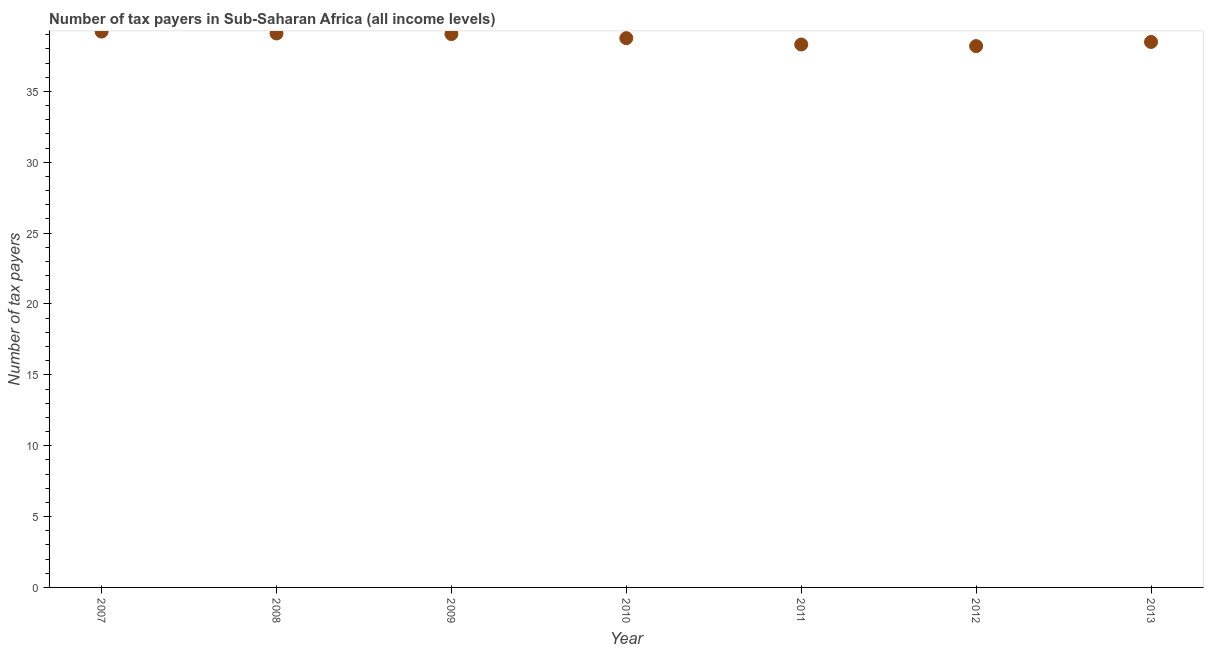What is the number of tax payers in 2011?
Provide a succinct answer. 38.31. Across all years, what is the maximum number of tax payers?
Your answer should be compact. 39.22. Across all years, what is the minimum number of tax payers?
Your answer should be compact. 38.2. In which year was the number of tax payers maximum?
Keep it short and to the point. 2007. What is the sum of the number of tax payers?
Make the answer very short. 271.11. What is the difference between the number of tax payers in 2009 and 2011?
Provide a short and direct response. 0.73. What is the average number of tax payers per year?
Make the answer very short. 38.73. What is the median number of tax payers?
Your answer should be compact. 38.76. Do a majority of the years between 2009 and 2008 (inclusive) have number of tax payers greater than 10 ?
Offer a terse response. No. What is the ratio of the number of tax payers in 2007 to that in 2010?
Ensure brevity in your answer.  1.01. Is the number of tax payers in 2009 less than that in 2010?
Make the answer very short. No. Is the difference between the number of tax payers in 2007 and 2009 greater than the difference between any two years?
Your response must be concise. No. What is the difference between the highest and the second highest number of tax payers?
Give a very brief answer. 0.13. Is the sum of the number of tax payers in 2007 and 2013 greater than the maximum number of tax payers across all years?
Your answer should be very brief. Yes. What is the difference between the highest and the lowest number of tax payers?
Your answer should be compact. 1.03. Does the number of tax payers monotonically increase over the years?
Provide a short and direct response. No. How many dotlines are there?
Ensure brevity in your answer.  1. How many years are there in the graph?
Your response must be concise. 7. What is the difference between two consecutive major ticks on the Y-axis?
Provide a short and direct response. 5. Does the graph contain any zero values?
Your answer should be compact. No. Does the graph contain grids?
Your answer should be compact. No. What is the title of the graph?
Ensure brevity in your answer.  Number of tax payers in Sub-Saharan Africa (all income levels). What is the label or title of the X-axis?
Make the answer very short. Year. What is the label or title of the Y-axis?
Provide a succinct answer. Number of tax payers. What is the Number of tax payers in 2007?
Your answer should be compact. 39.22. What is the Number of tax payers in 2008?
Make the answer very short. 39.09. What is the Number of tax payers in 2009?
Offer a terse response. 39.04. What is the Number of tax payers in 2010?
Ensure brevity in your answer.  38.76. What is the Number of tax payers in 2011?
Ensure brevity in your answer.  38.31. What is the Number of tax payers in 2012?
Keep it short and to the point. 38.2. What is the Number of tax payers in 2013?
Provide a short and direct response. 38.49. What is the difference between the Number of tax payers in 2007 and 2008?
Provide a short and direct response. 0.13. What is the difference between the Number of tax payers in 2007 and 2009?
Provide a succinct answer. 0.18. What is the difference between the Number of tax payers in 2007 and 2010?
Offer a terse response. 0.47. What is the difference between the Number of tax payers in 2007 and 2011?
Your response must be concise. 0.91. What is the difference between the Number of tax payers in 2007 and 2012?
Ensure brevity in your answer.  1.03. What is the difference between the Number of tax payers in 2007 and 2013?
Provide a succinct answer. 0.73. What is the difference between the Number of tax payers in 2008 and 2009?
Provide a short and direct response. 0.04. What is the difference between the Number of tax payers in 2008 and 2010?
Offer a very short reply. 0.33. What is the difference between the Number of tax payers in 2008 and 2011?
Keep it short and to the point. 0.78. What is the difference between the Number of tax payers in 2008 and 2012?
Your answer should be compact. 0.89. What is the difference between the Number of tax payers in 2008 and 2013?
Give a very brief answer. 0.6. What is the difference between the Number of tax payers in 2009 and 2010?
Your answer should be very brief. 0.29. What is the difference between the Number of tax payers in 2009 and 2011?
Offer a very short reply. 0.73. What is the difference between the Number of tax payers in 2009 and 2012?
Your response must be concise. 0.85. What is the difference between the Number of tax payers in 2009 and 2013?
Make the answer very short. 0.56. What is the difference between the Number of tax payers in 2010 and 2011?
Provide a succinct answer. 0.44. What is the difference between the Number of tax payers in 2010 and 2012?
Your response must be concise. 0.56. What is the difference between the Number of tax payers in 2010 and 2013?
Your answer should be very brief. 0.27. What is the difference between the Number of tax payers in 2011 and 2012?
Make the answer very short. 0.12. What is the difference between the Number of tax payers in 2011 and 2013?
Provide a short and direct response. -0.18. What is the difference between the Number of tax payers in 2012 and 2013?
Ensure brevity in your answer.  -0.29. What is the ratio of the Number of tax payers in 2007 to that in 2008?
Your response must be concise. 1. What is the ratio of the Number of tax payers in 2007 to that in 2009?
Keep it short and to the point. 1. What is the ratio of the Number of tax payers in 2007 to that in 2011?
Make the answer very short. 1.02. What is the ratio of the Number of tax payers in 2007 to that in 2012?
Provide a short and direct response. 1.03. What is the ratio of the Number of tax payers in 2008 to that in 2009?
Provide a succinct answer. 1. What is the ratio of the Number of tax payers in 2008 to that in 2010?
Keep it short and to the point. 1.01. What is the ratio of the Number of tax payers in 2008 to that in 2012?
Make the answer very short. 1.02. What is the ratio of the Number of tax payers in 2008 to that in 2013?
Make the answer very short. 1.02. What is the ratio of the Number of tax payers in 2009 to that in 2011?
Provide a short and direct response. 1.02. What is the ratio of the Number of tax payers in 2010 to that in 2011?
Your answer should be compact. 1.01. What is the ratio of the Number of tax payers in 2011 to that in 2012?
Your response must be concise. 1. What is the ratio of the Number of tax payers in 2011 to that in 2013?
Give a very brief answer. 0.99. 